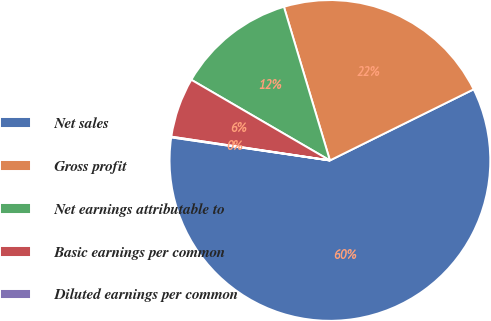<chart> <loc_0><loc_0><loc_500><loc_500><pie_chart><fcel>Net sales<fcel>Gross profit<fcel>Net earnings attributable to<fcel>Basic earnings per common<fcel>Diluted earnings per common<nl><fcel>59.61%<fcel>22.32%<fcel>11.98%<fcel>6.02%<fcel>0.07%<nl></chart> 